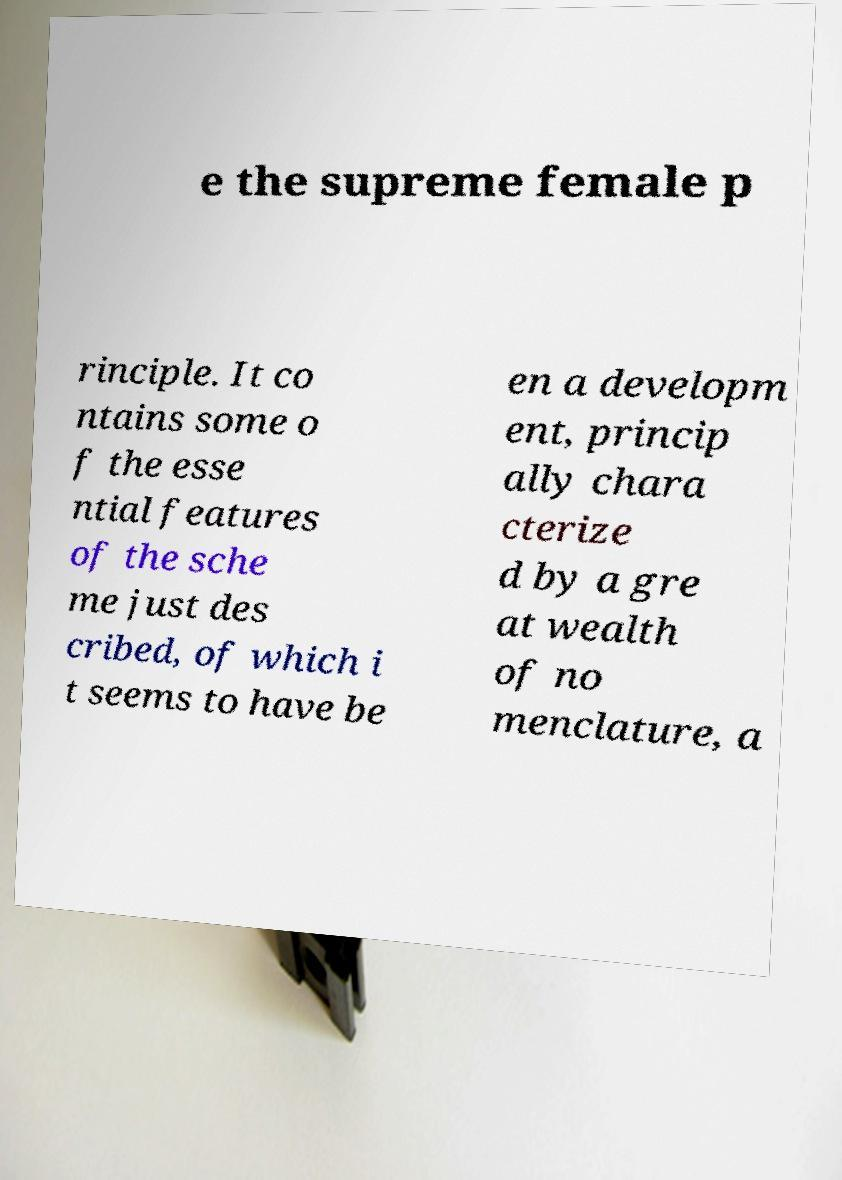Could you assist in decoding the text presented in this image and type it out clearly? e the supreme female p rinciple. It co ntains some o f the esse ntial features of the sche me just des cribed, of which i t seems to have be en a developm ent, princip ally chara cterize d by a gre at wealth of no menclature, a 